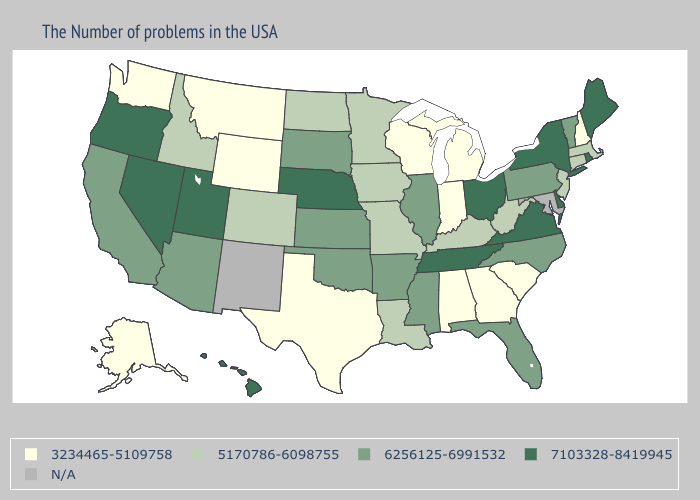How many symbols are there in the legend?
Concise answer only. 5. What is the lowest value in the USA?
Write a very short answer. 3234465-5109758. Does Kentucky have the highest value in the South?
Concise answer only. No. How many symbols are there in the legend?
Be succinct. 5. Name the states that have a value in the range 6256125-6991532?
Keep it brief. Vermont, Pennsylvania, North Carolina, Florida, Illinois, Mississippi, Arkansas, Kansas, Oklahoma, South Dakota, Arizona, California. Which states have the lowest value in the Northeast?
Write a very short answer. New Hampshire. Which states have the lowest value in the USA?
Write a very short answer. New Hampshire, South Carolina, Georgia, Michigan, Indiana, Alabama, Wisconsin, Texas, Wyoming, Montana, Washington, Alaska. What is the value of Maryland?
Give a very brief answer. N/A. Does Montana have the lowest value in the West?
Concise answer only. Yes. What is the value of New Mexico?
Be succinct. N/A. Name the states that have a value in the range N/A?
Concise answer only. Maryland, New Mexico. What is the value of South Dakota?
Keep it brief. 6256125-6991532. What is the value of Mississippi?
Quick response, please. 6256125-6991532. Name the states that have a value in the range 7103328-8419945?
Quick response, please. Maine, Rhode Island, New York, Delaware, Virginia, Ohio, Tennessee, Nebraska, Utah, Nevada, Oregon, Hawaii. Name the states that have a value in the range N/A?
Answer briefly. Maryland, New Mexico. 